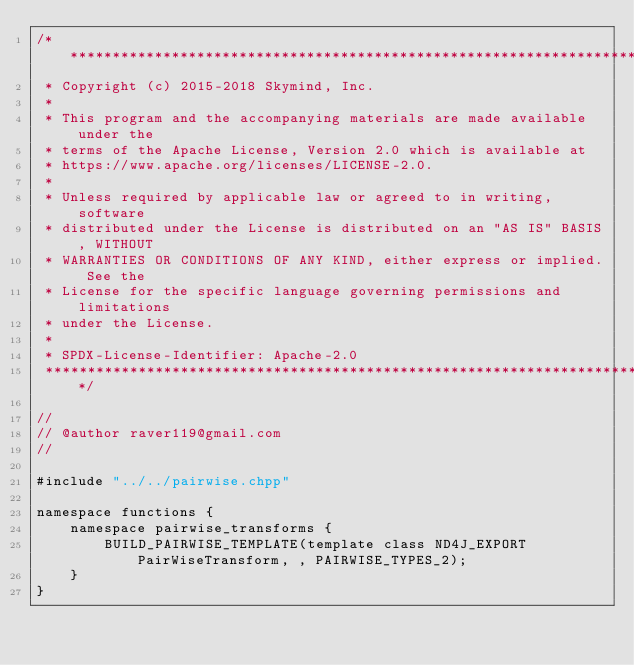<code> <loc_0><loc_0><loc_500><loc_500><_Cuda_>/*******************************************************************************
 * Copyright (c) 2015-2018 Skymind, Inc.
 *
 * This program and the accompanying materials are made available under the
 * terms of the Apache License, Version 2.0 which is available at
 * https://www.apache.org/licenses/LICENSE-2.0.
 *
 * Unless required by applicable law or agreed to in writing, software
 * distributed under the License is distributed on an "AS IS" BASIS, WITHOUT
 * WARRANTIES OR CONDITIONS OF ANY KIND, either express or implied. See the
 * License for the specific language governing permissions and limitations
 * under the License.
 *
 * SPDX-License-Identifier: Apache-2.0
 ******************************************************************************/

//
// @author raver119@gmail.com
//

#include "../../pairwise.chpp"

namespace functions {
    namespace pairwise_transforms {
        BUILD_PAIRWISE_TEMPLATE(template class ND4J_EXPORT PairWiseTransform, , PAIRWISE_TYPES_2);
    }
}</code> 